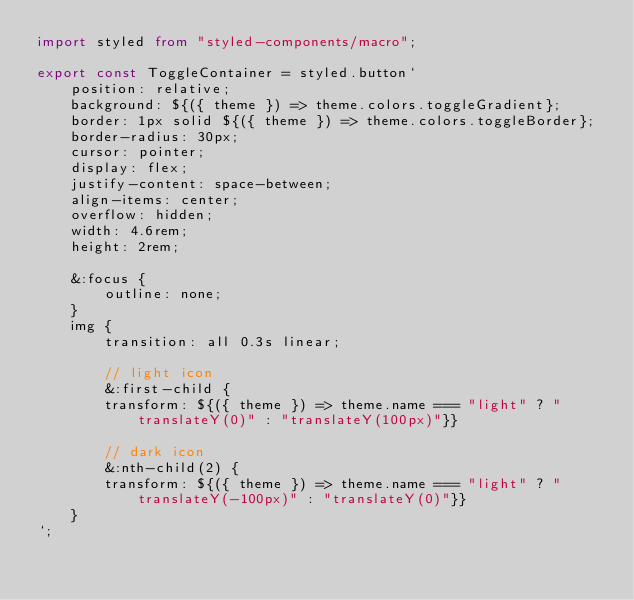<code> <loc_0><loc_0><loc_500><loc_500><_TypeScript_>import styled from "styled-components/macro";

export const ToggleContainer = styled.button`
    position: relative;
    background: ${({ theme }) => theme.colors.toggleGradient};
    border: 1px solid ${({ theme }) => theme.colors.toggleBorder};
    border-radius: 30px;
    cursor: pointer;
    display: flex;
    justify-content: space-between;
    align-items: center;
    overflow: hidden;
    width: 4.6rem;
    height: 2rem;

    &:focus {
        outline: none;
    }
    img {
        transition: all 0.3s linear;

        // light icon
        &:first-child {
        transform: ${({ theme }) => theme.name === "light" ? "translateY(0)" : "translateY(100px)"}}
    
        // dark icon
        &:nth-child(2) {
        transform: ${({ theme }) => theme.name === "light" ? "translateY(-100px)" : "translateY(0)"}}
    }
`;
</code> 